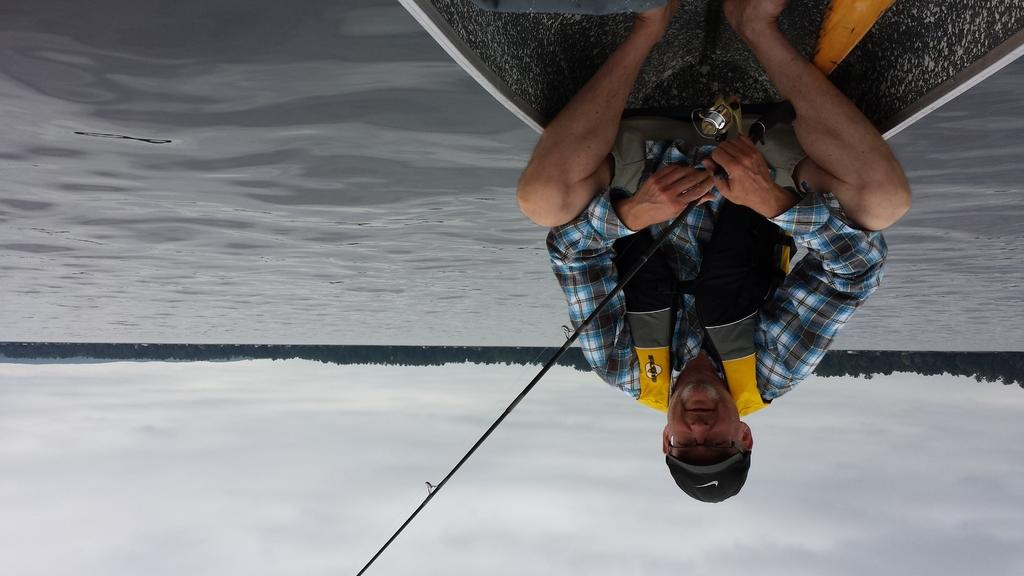How is the image presented in terms of orientation? The image is inverted. What is the man in the image doing? The man is sitting in a boat. What is the boat doing in the image? The boat is sailing on the water surface. What can be seen in the background of the image? There are trees in the background of the image. How many apples can be seen in the man's hand in the image? There are no apples present in the image; the man is sitting in a boat sailing on the water surface. Can you describe the bite marks on the apples in the image? There are no apples or bite marks present in the image. 